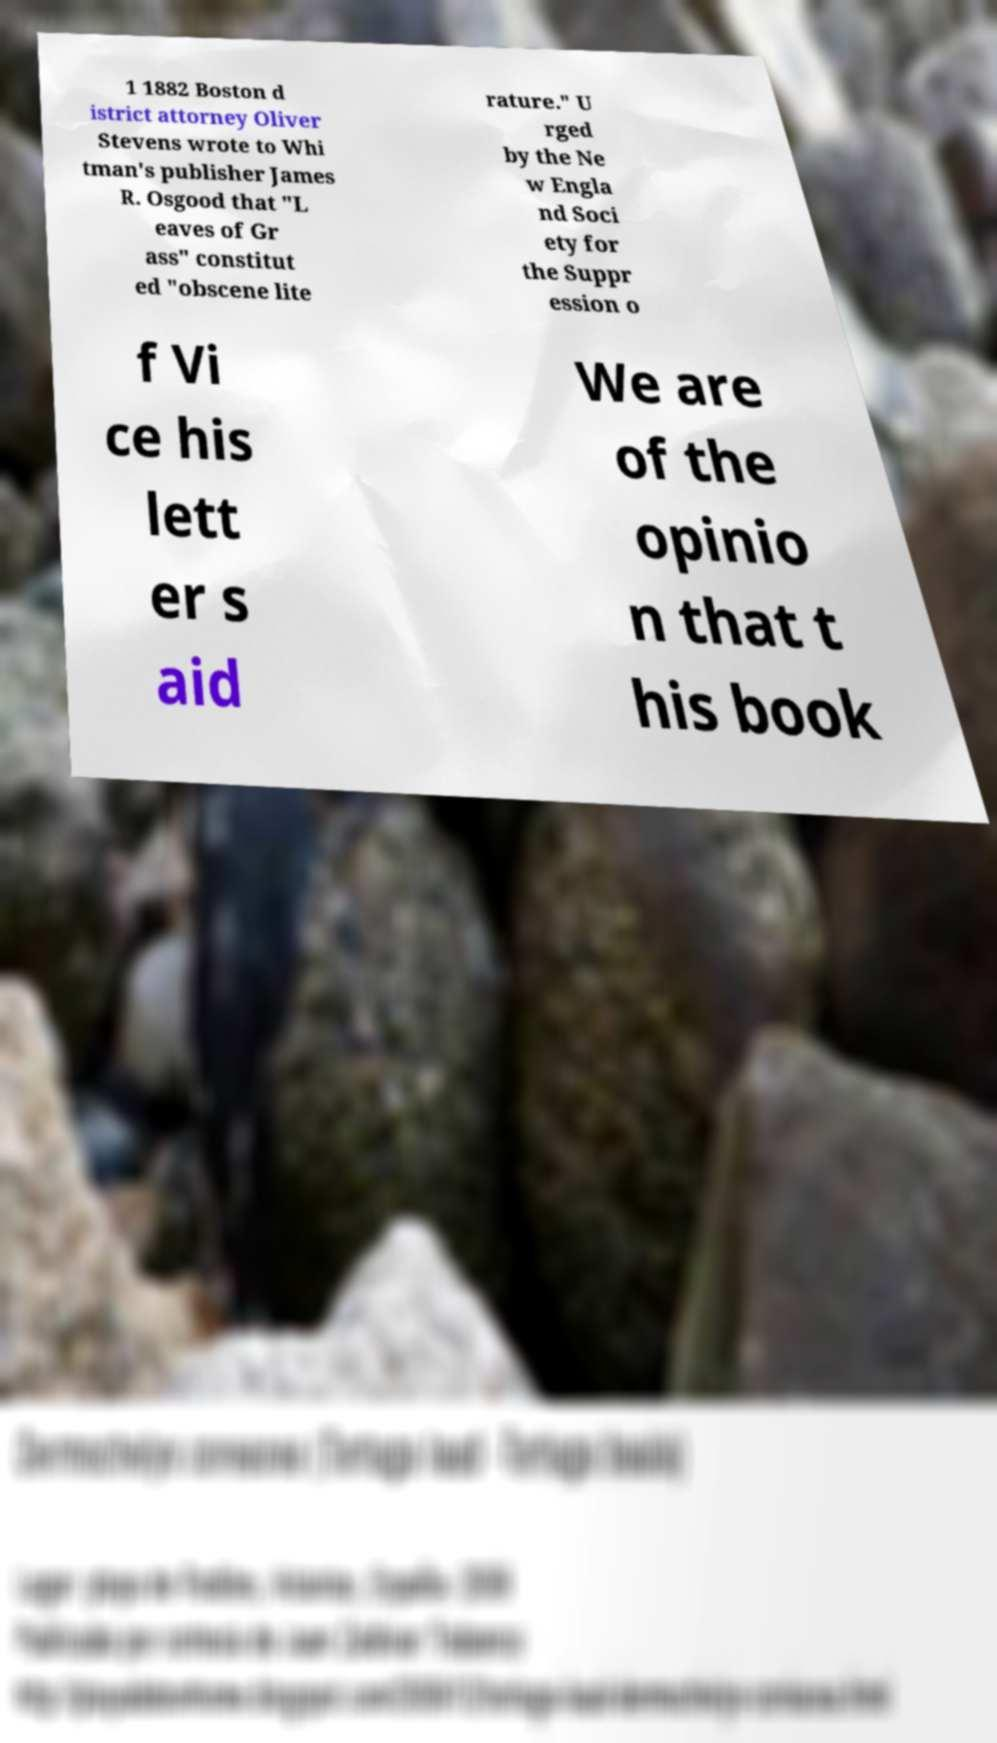I need the written content from this picture converted into text. Can you do that? 1 1882 Boston d istrict attorney Oliver Stevens wrote to Whi tman's publisher James R. Osgood that "L eaves of Gr ass" constitut ed "obscene lite rature." U rged by the Ne w Engla nd Soci ety for the Suppr ession o f Vi ce his lett er s aid We are of the opinio n that t his book 